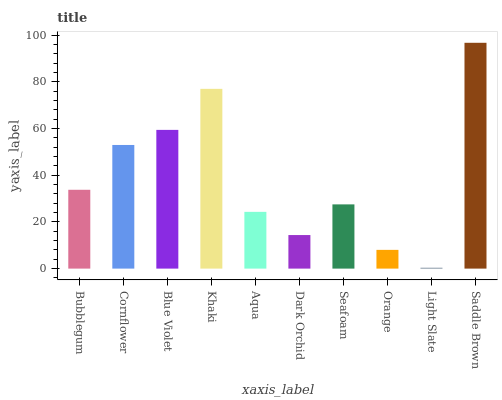Is Light Slate the minimum?
Answer yes or no. Yes. Is Saddle Brown the maximum?
Answer yes or no. Yes. Is Cornflower the minimum?
Answer yes or no. No. Is Cornflower the maximum?
Answer yes or no. No. Is Cornflower greater than Bubblegum?
Answer yes or no. Yes. Is Bubblegum less than Cornflower?
Answer yes or no. Yes. Is Bubblegum greater than Cornflower?
Answer yes or no. No. Is Cornflower less than Bubblegum?
Answer yes or no. No. Is Bubblegum the high median?
Answer yes or no. Yes. Is Seafoam the low median?
Answer yes or no. Yes. Is Seafoam the high median?
Answer yes or no. No. Is Dark Orchid the low median?
Answer yes or no. No. 